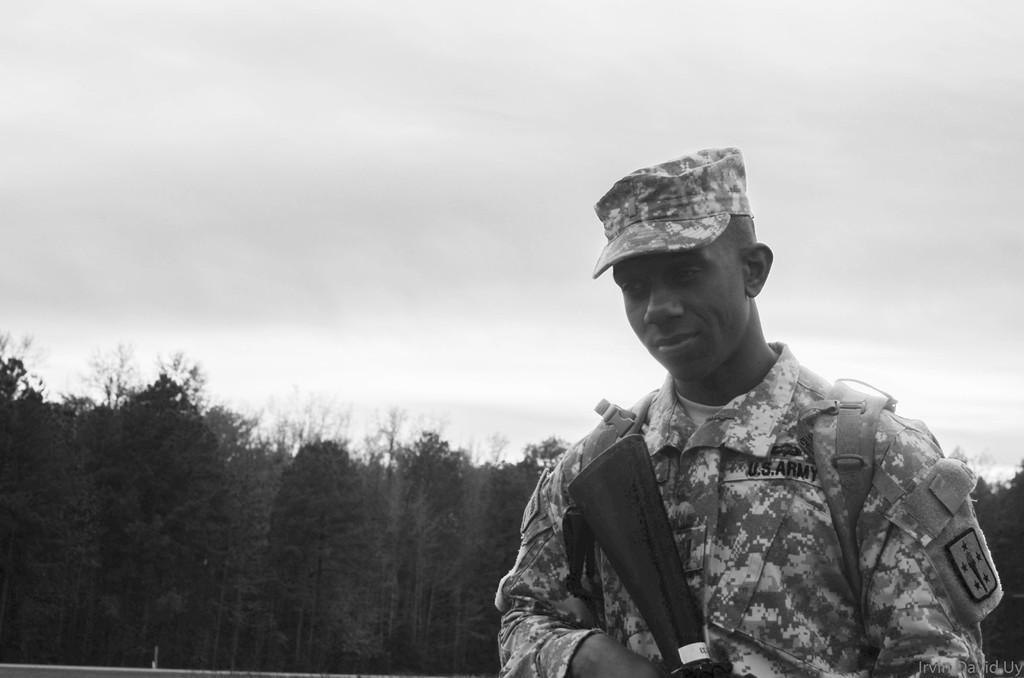Please provide a concise description of this image. On the right side, there is a person in a uniform, wearing a cap and holding a gun. In the background, there are trees on the ground and there are clouds in the sky. 